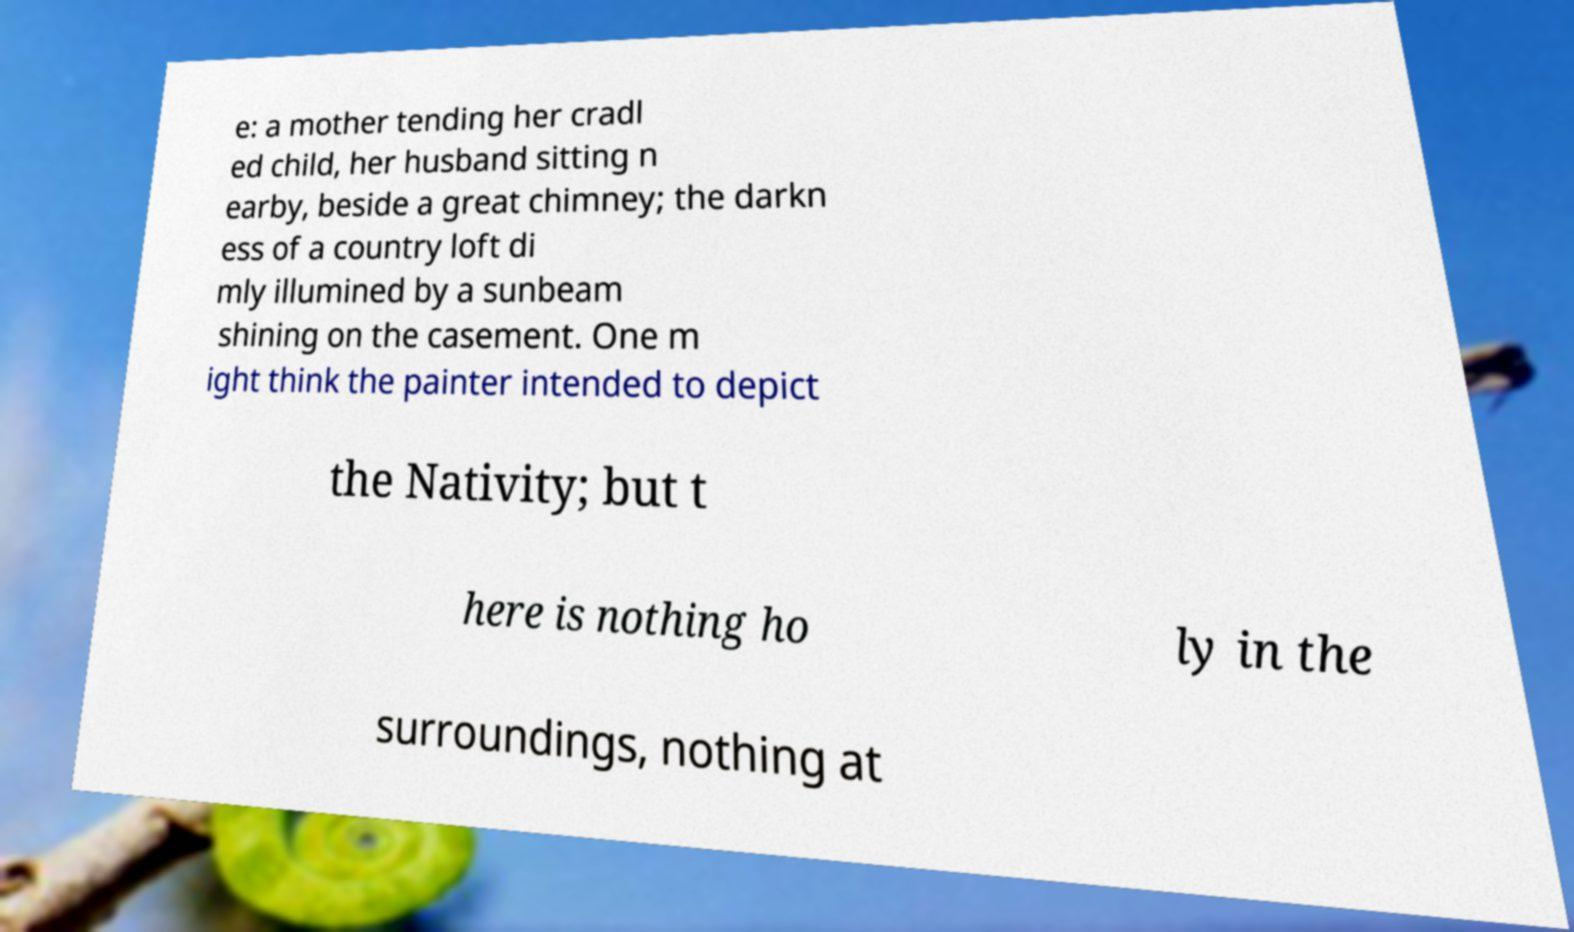There's text embedded in this image that I need extracted. Can you transcribe it verbatim? e: a mother tending her cradl ed child, her husband sitting n earby, beside a great chimney; the darkn ess of a country loft di mly illumined by a sunbeam shining on the casement. One m ight think the painter intended to depict the Nativity; but t here is nothing ho ly in the surroundings, nothing at 